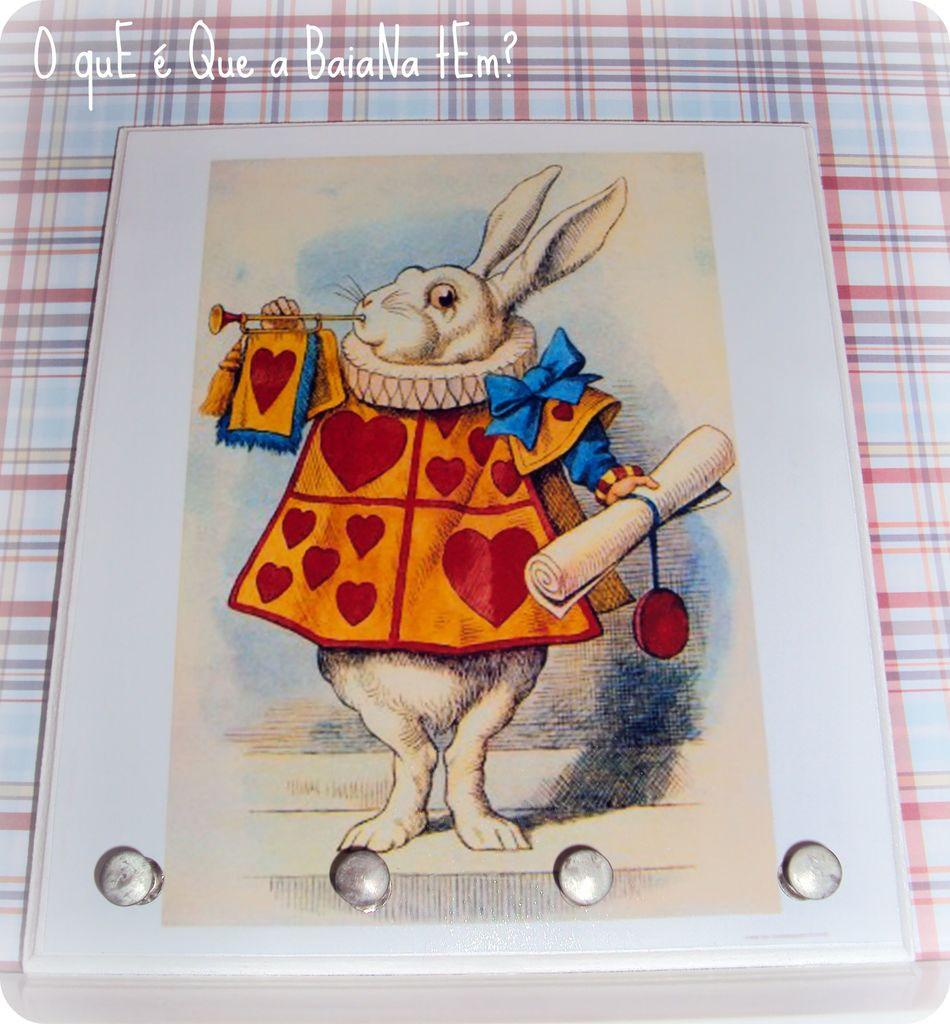What animal is present in the image? There is a rabbit in the image. What is the rabbit doing with its hands? The rabbit is holding objects in its hands. Can you describe any additional elements in the image? There is text on top of the image. Is the rabbit drinking milk in the image? There is no milk present in the image, and the rabbit is not depicted drinking anything. 